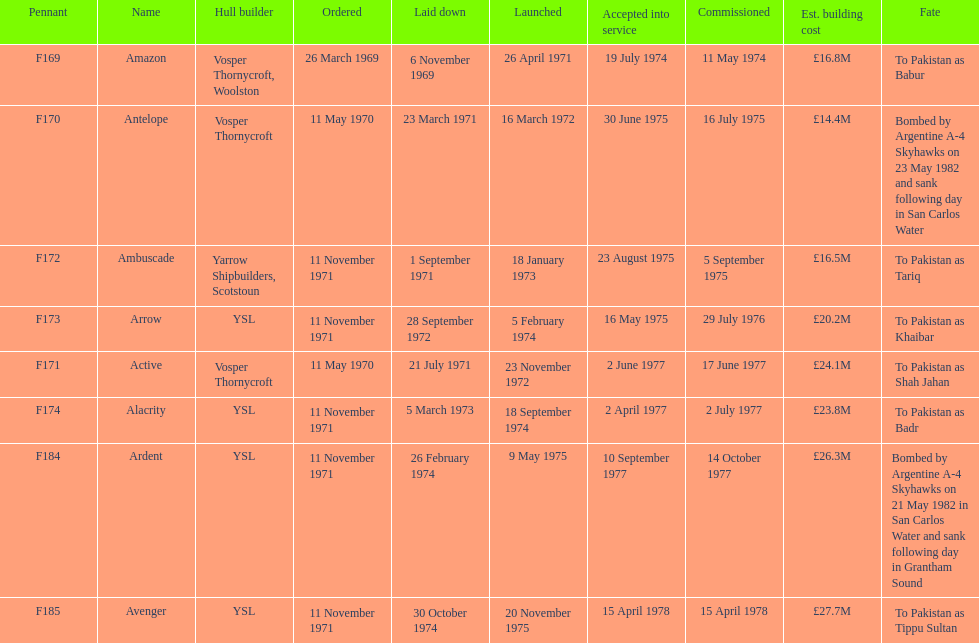What is the subsequent pennant to f172? F173. 